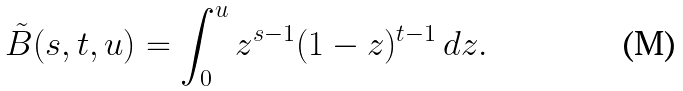<formula> <loc_0><loc_0><loc_500><loc_500>\tilde { B } ( s , t , u ) = \int _ { 0 } ^ { u } z ^ { s - 1 } ( 1 - z ) ^ { t - 1 } \, d z .</formula> 